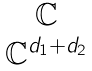<formula> <loc_0><loc_0><loc_500><loc_500>\begin{matrix} \mathbb { C } \\ \mathbb { C } ^ { d _ { 1 } + d _ { 2 } } \end{matrix}</formula> 